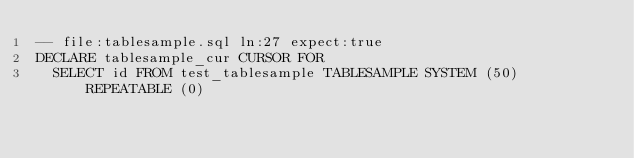Convert code to text. <code><loc_0><loc_0><loc_500><loc_500><_SQL_>-- file:tablesample.sql ln:27 expect:true
DECLARE tablesample_cur CURSOR FOR
  SELECT id FROM test_tablesample TABLESAMPLE SYSTEM (50) REPEATABLE (0)
</code> 